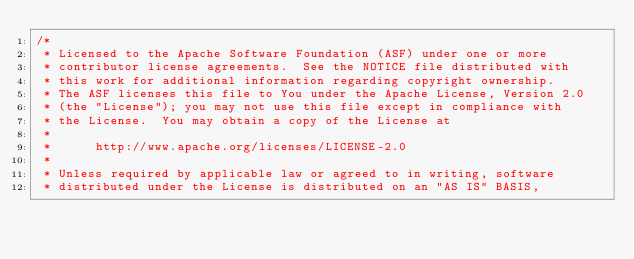<code> <loc_0><loc_0><loc_500><loc_500><_Java_>/*
 * Licensed to the Apache Software Foundation (ASF) under one or more
 * contributor license agreements.  See the NOTICE file distributed with
 * this work for additional information regarding copyright ownership.
 * The ASF licenses this file to You under the Apache License, Version 2.0
 * (the "License"); you may not use this file except in compliance with
 * the License.  You may obtain a copy of the License at
 *
 *      http://www.apache.org/licenses/LICENSE-2.0
 *
 * Unless required by applicable law or agreed to in writing, software
 * distributed under the License is distributed on an "AS IS" BASIS,</code> 